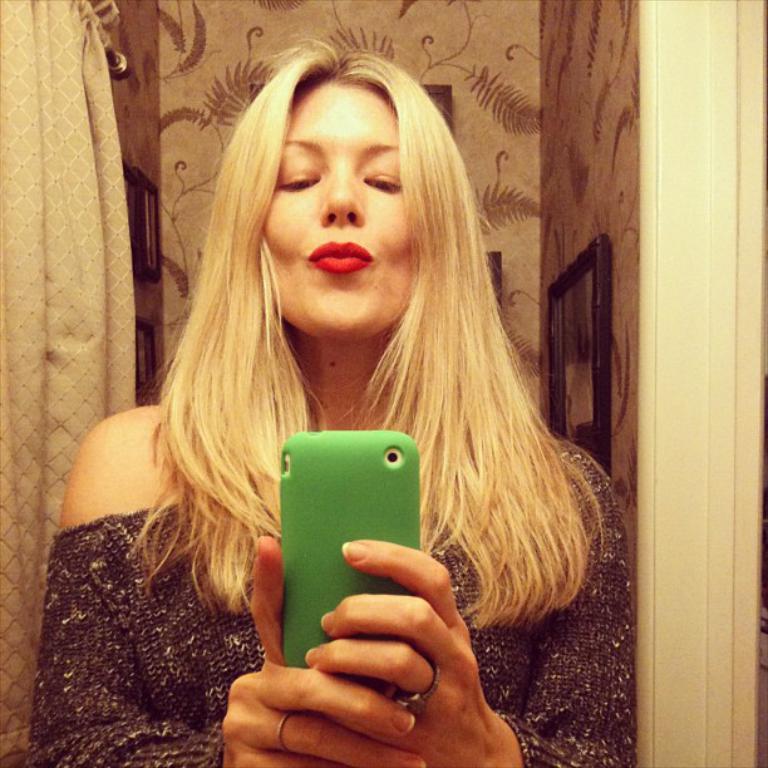Can you describe this image briefly? In the image we can see there is a woman who is standing and she is holding a mobile phone in her hand and at the back there are curtains and wall. 